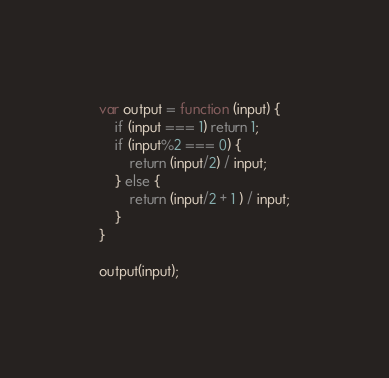<code> <loc_0><loc_0><loc_500><loc_500><_JavaScript_>var output = function (input) {
	if (input === 1) return 1;
    if (input%2 === 0) {
    	return (input/2) / input;
    } else {
    	return (input/2 + 1 ) / input;
    }
}

output(input);</code> 